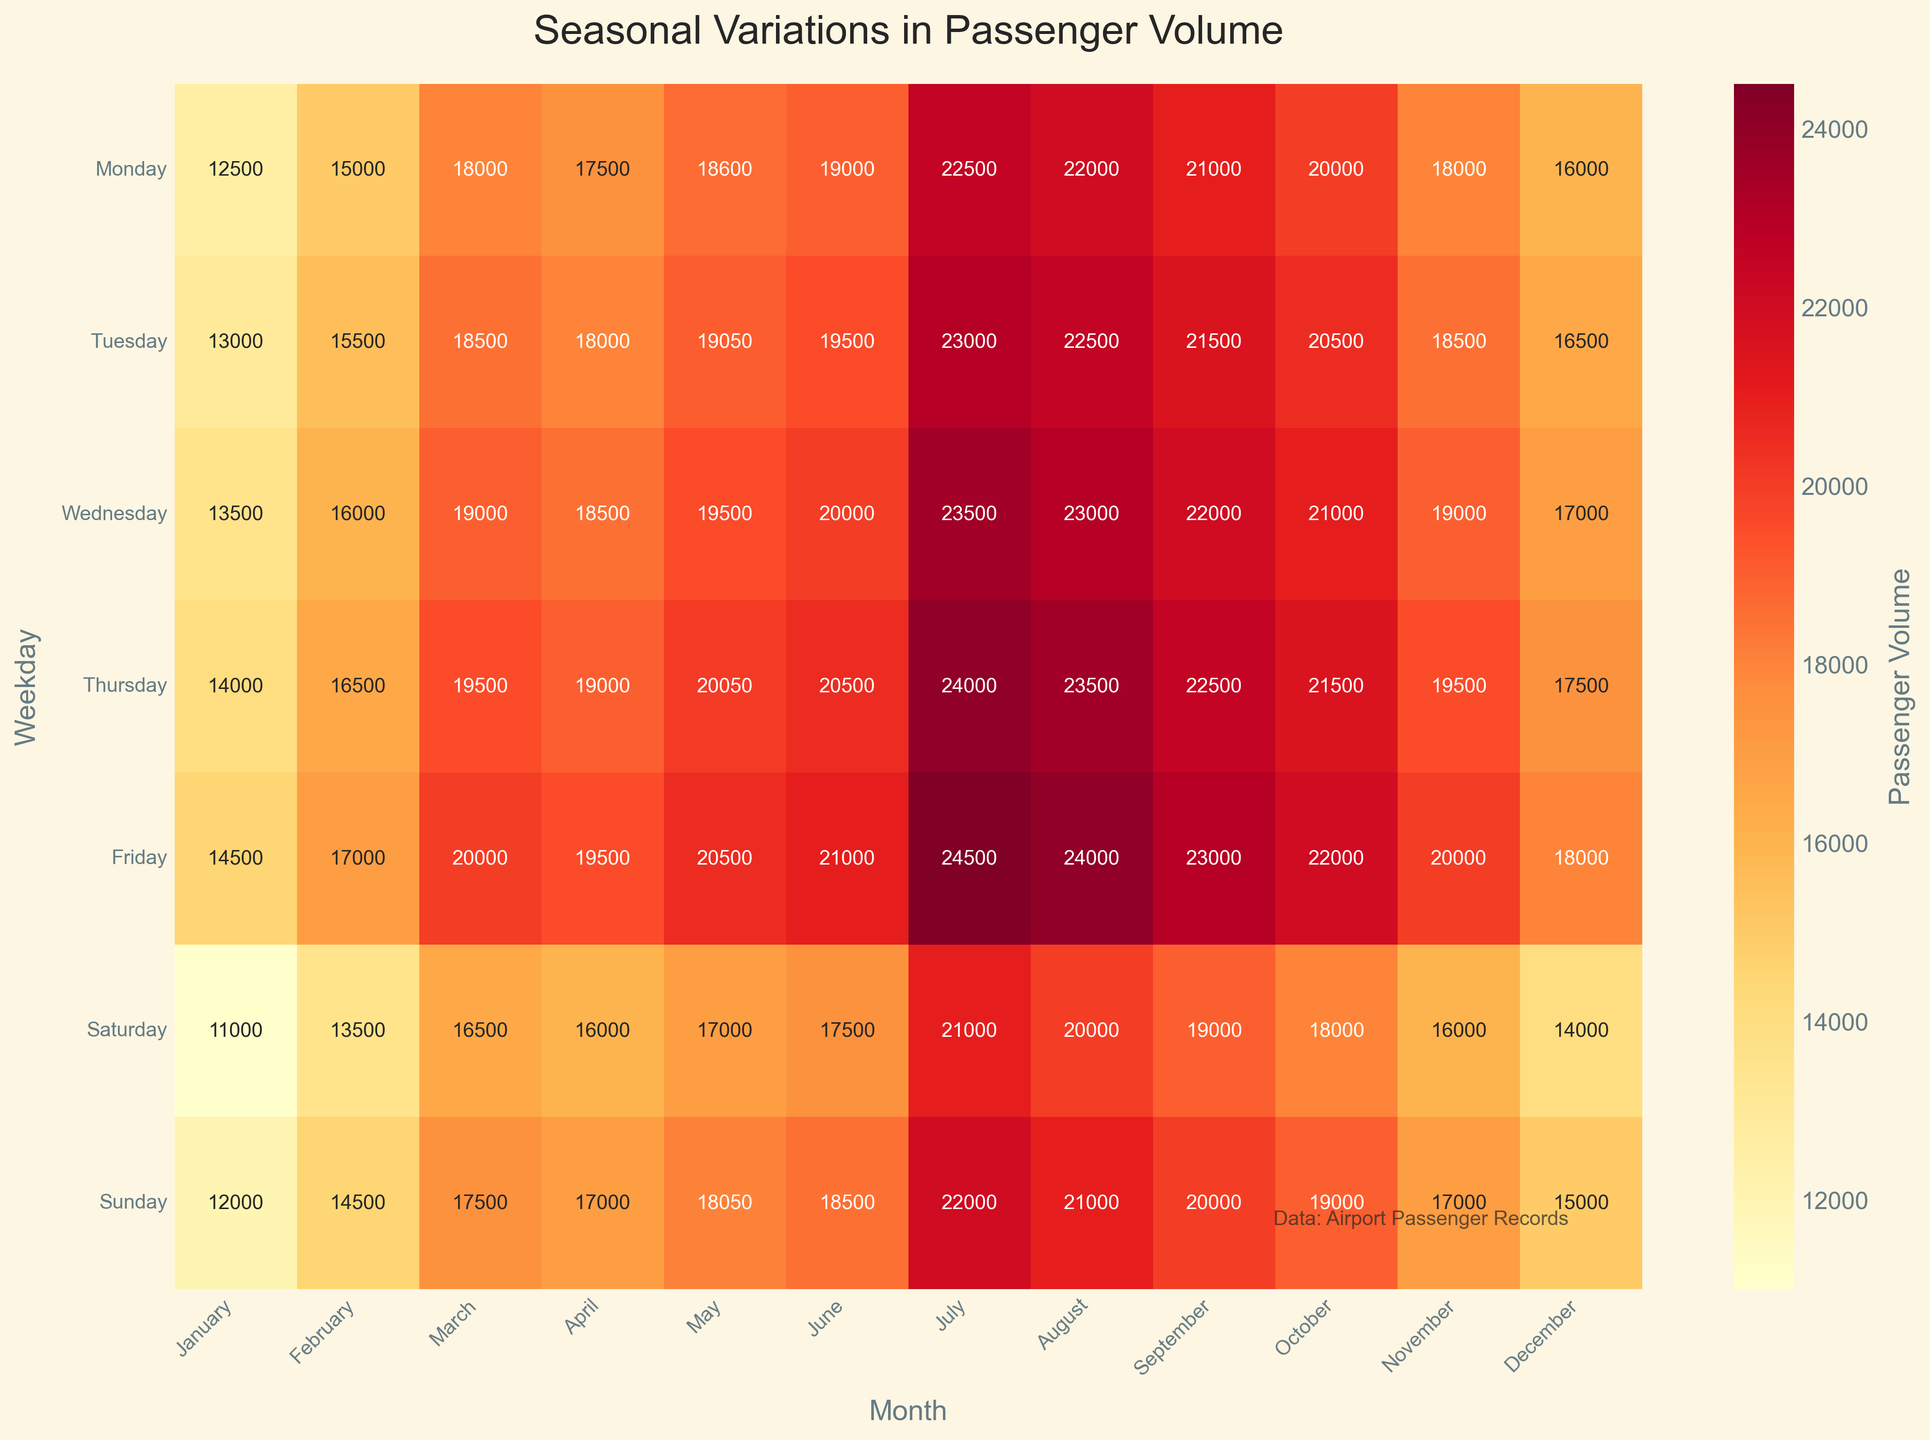What is the title of the heatmap? The title of the plot is displayed at the top center of the figure. It reads "Seasonal Variations in Passenger Volume".
Answer: Seasonal Variations in Passenger Volume Which weekday and month combination has the highest passenger volume? By observing the heatmap, the combination with the darkest shade of the color used (indicative of the highest value) is found. The row labeled "Friday" and the column labeled "July" intersect at the highest value of 24500 passengers.
Answer: Friday in July What is the average passenger volume on Mondays across all months? Calculate the average by adding up the passenger volumes for Monday across all months and then dividing by the number of months: (12500 + 15000 + 18000 + 17500 + 18600 + 19000 + 22500 + 22000 + 21000 + 20000 + 18000 + 16000) / 12 = (230100 / 12). The result is approximately 19175.
Answer: 19175 Which day of the week generally has the lowest passenger volume in February? Identify the row in February with the smallest number. By checking the values under February, Saturday has the lowest passenger volume with 13500.
Answer: Saturday Find the month with the lowest passenger volume on Sundays and state the volume. Look at the Sunday row and find the column with the lightest shade, which corresponds to the lowest value. December has the lowest volume with 15000 passengers.
Answer: December, 15000 On which weekday does the passenger volume increase the most from February to March? Calculate the increase in passenger volume for each weekday from February to March by subtracting the February volumes from the March volumes and identify the highest difference. - Monday: 18000 - 15000 = 3000 - Tuesday: 18500 - 15500 = 3000 - Wednesday: 19000 - 16000 = 3000 - Thursday: 19500 - 16500 = 3000 - Friday: 20000 - 17000 = 3000 - Saturday: 16500 - 13500 = 3000 - Sunday: 17500 - 14500 = 3000. All weekdays have the same increase of 3000 passengers.
Answer: All weekdays (3000) Which day of the week shows the largest variation in passenger volume throughout the year? Calculate the range (difference between max and min values) for each day. Monday: 22500 - 12500 = 10000; Tuesday: 23000 - 13000 = 10000; Wednesday: 23500 - 13500 = 10000; Thursday: 24000 - 14000 = 10000; Friday: 24500 - 14500 = 10000; Saturday: 21000 - 11000 = 10000; Sunday: 22000 - 12000 = 10000. The range is the same for all days, 10000.
Answer: All weekdays (10000) In which month is the passenger volume more uniformly distributed across all days of the week? Uniform distribution means less variation in passenger volumes. Check for the month where the maximum and minimum values are closest. January: range = 14500 -11000 = 3500, February: range = 17000 - 13500 = 3500, March: range = 20000 - 16500 = 3500, April: range = 19500 - 16000 = 3500, May: range = 20500 - 17000 = 3500, June: range = 21000 - 17500 = 3500, July: range = 24500 - 21000 = 3500, August: range = 23500 - 20000 = 3500, September: range = 23000 - 19000 = 4000, October: range = 22000 - 18000 = 4000, November: range = 20000 - 16000 = 4000, December: range = 18000 - 14000 = 4000. All months show very similar ranges, ranging between 3500 and 4000, thus uniformly distributed.
Answer: All months (similar ranges) Which months have a higher passenger volume during weekends (Saturday and Sunday) compared to weekdays? Calculate the average passenger volume for weekends and weekdays for each month and compare. Calculate average for Saturdays and Sundays vs all other weekdays. For detailed comparisons, it is necessary to sum up and compare each month's weekend and weekday average values respectively. All weekends volume are generally higher in the summer months. Detailed analysis: January: (11000 + 12000) < (12500 + 13000 + 13500 + 14000 + 14500); February: (13500 + 14500) < (15000 + 15500 + 16000 + 16500 + 17000); March: (16500 + 17500) < (18000 + 18500 + 19000 + 19500 + 20000);... Rest of the months in similar pattern
Answer: Generally Higher in Summer months What trends do you observe in passenger volume from January to December? Observation shows that passenger volume increases towards the middle of the year (peaks during the summer), and then declines towards the end. This pattern repeats consistently for every weekday. This suggests a seasonality effect where passenger volumes are highest during summer.
Answer: Increases mid-year, peaks in summer, declines end-year 